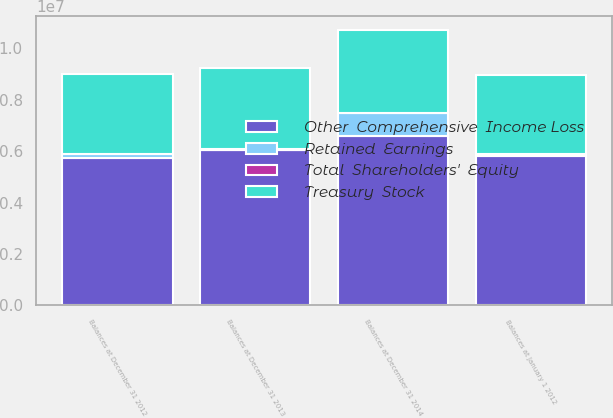Convert chart to OTSL. <chart><loc_0><loc_0><loc_500><loc_500><stacked_bar_chart><ecel><fcel>Balances at January 1 2012<fcel>Balances at December 31 2012<fcel>Balances at December 31 2013<fcel>Balances at December 31 2014<nl><fcel>Total  Shareholders'  Equity<fcel>2276<fcel>2291<fcel>2308<fcel>2331<nl><fcel>Treasury  Stock<fcel>3.07176e+06<fcel>3.10989e+06<fcel>3.15904e+06<fcel>3.25355e+06<nl><fcel>Other  Comprehensive  Income Loss<fcel>5.82343e+06<fcel>5.74479e+06<fcel>6.05495e+06<fcel>6.57525e+06<nl><fcel>Retained  Earnings<fcel>75938<fcel>134516<fcel>5671<fcel>896994<nl></chart> 